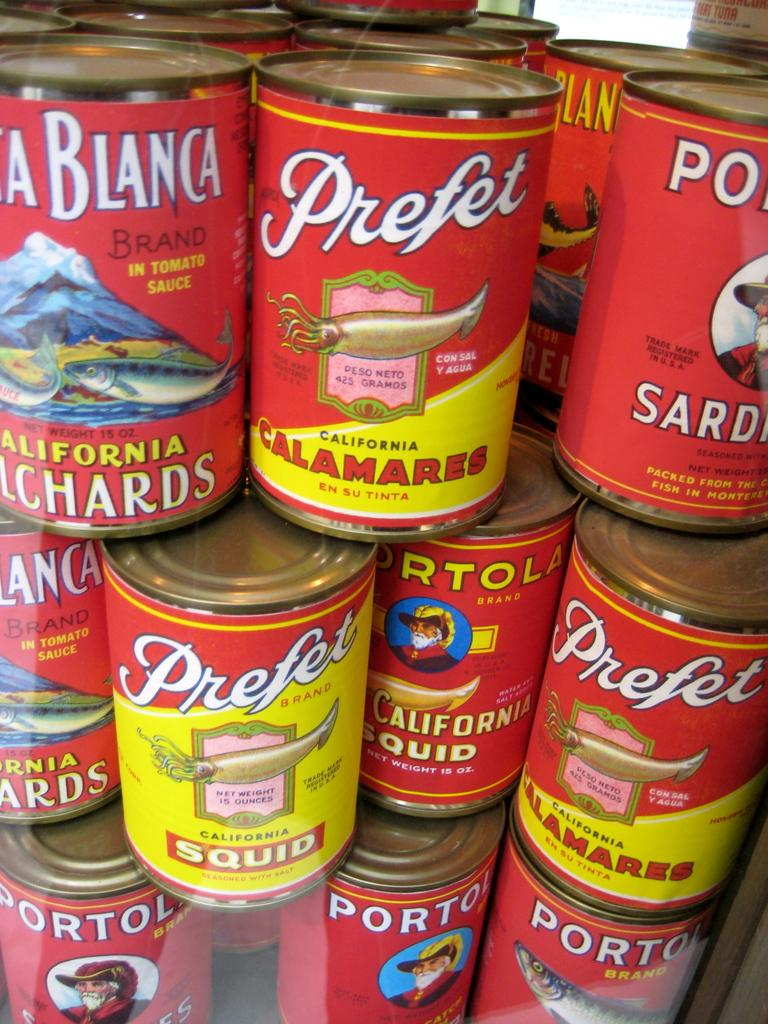<image>
Relay a brief, clear account of the picture shown. Numerous cans of seafood called Prefet are stacked. 